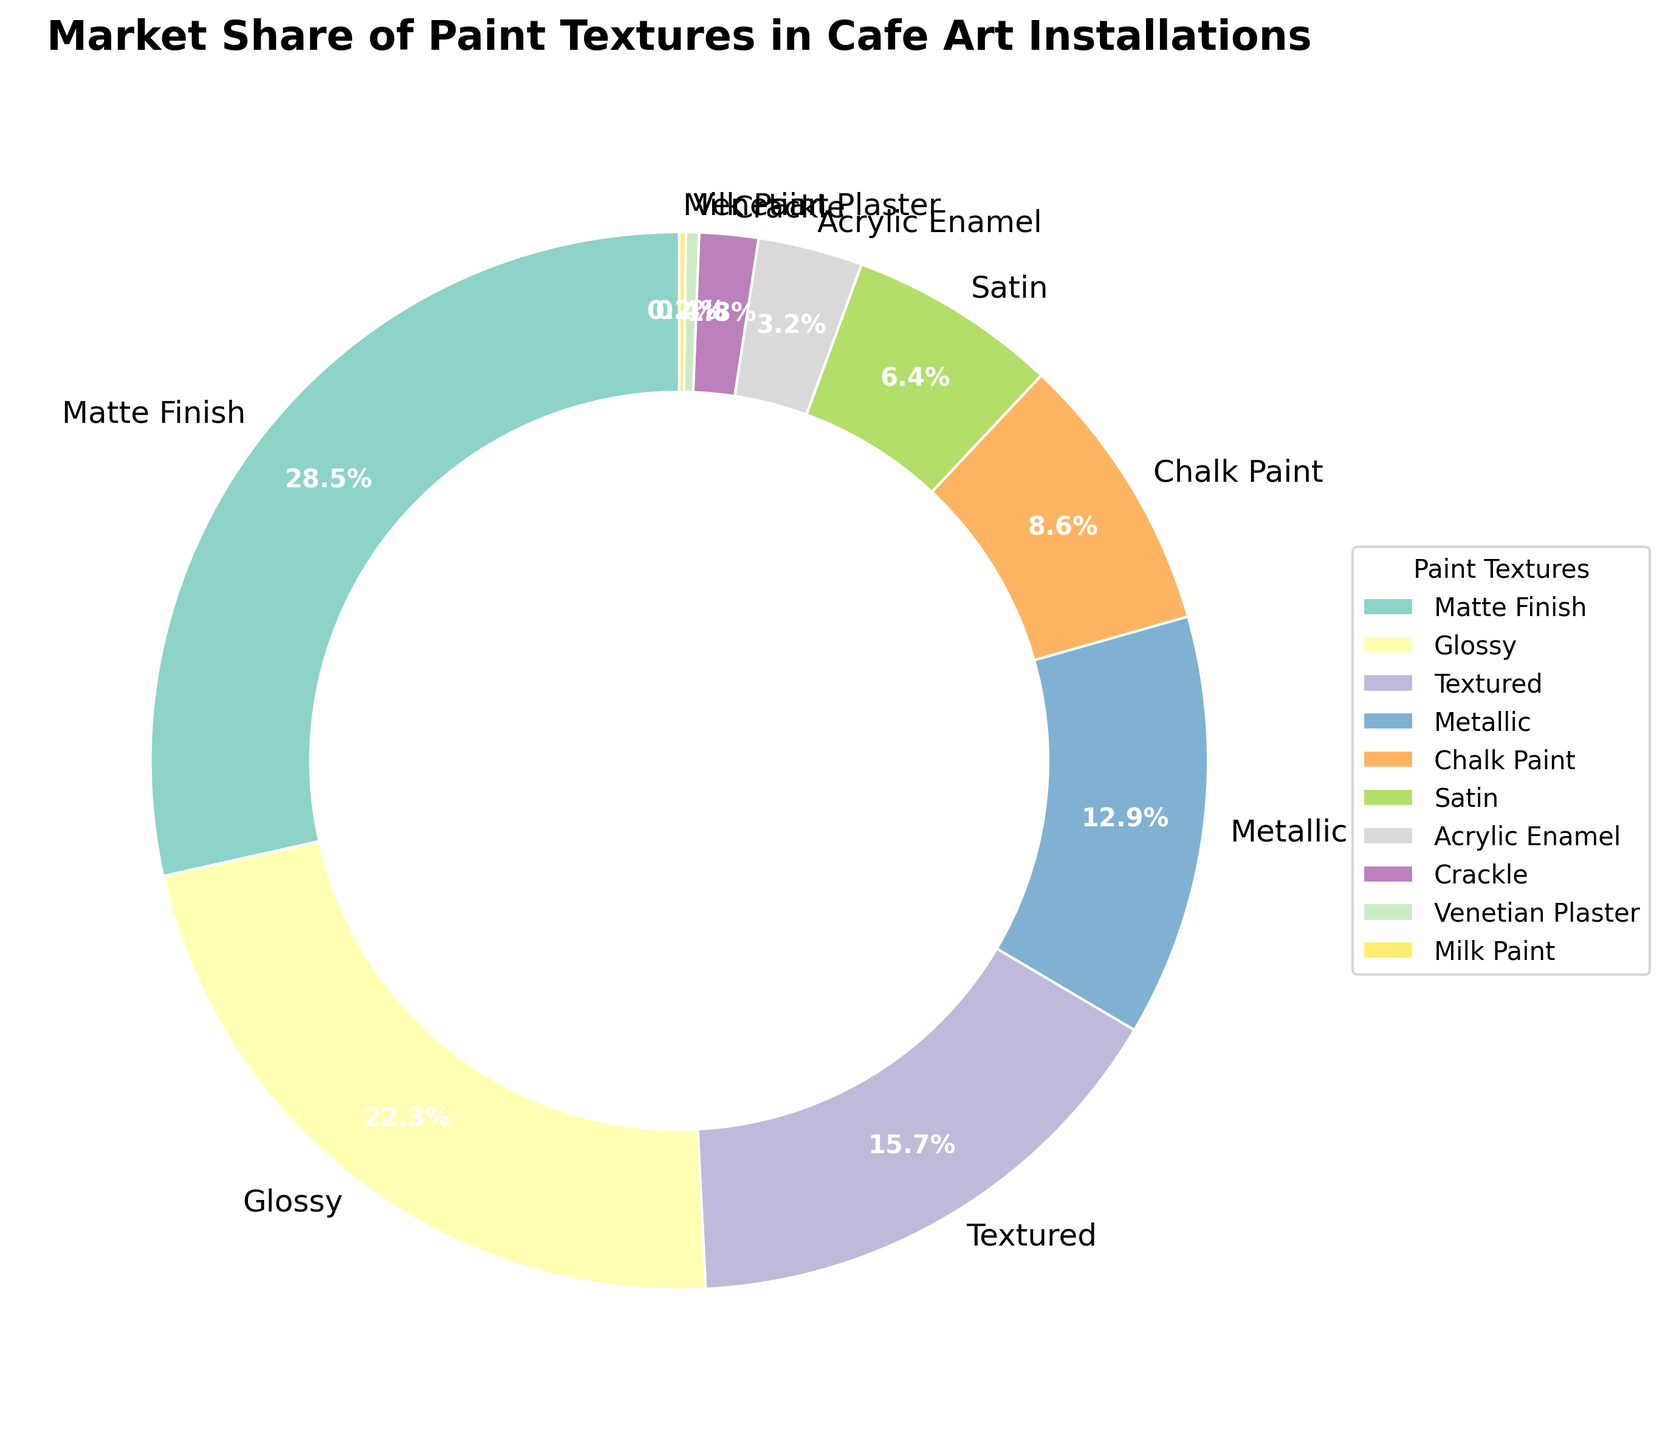Which paint texture has the largest market share? To determine the largest market share, look for the segment with the highest percentage. The "Matte Finish" segment has the largest label showing 28.5%.
Answer: Matte Finish How much more market share does Matte Finish have compared to Glossy? Subtract the market share of Glossy (22.3%) from that of Matte Finish (28.5%): 28.5% - 22.3% = 6.2%.
Answer: 6.2% What is the combined market share of Textured, Metallic, and Chalk Paint? Add the market shares of Textured (15.7%), Metallic (12.9%), and Chalk Paint (8.6%): 15.7% + 12.9% + 8.6% = 37.2%.
Answer: 37.2% Which paint texture has the smallest market share and what is its value? Look for the smallest segment by percentage. The "Milk Paint" segment is the smallest with a label showing 0.2%.
Answer: Milk Paint, 0.2% Are there more paint textures with a market share above or below 10%? Count the textures above 10% (Matte Finish, Glossy, Textured, Metallic – 4 textures) and below 10% (Chalk Paint, Satin, Acrylic Enamel, Crackle, Venetian Plaster, Milk Paint – 6 textures). Since 6 is greater than 4, there are more paint textures below 10%.
Answer: Below Which two paint textures combined contribute more than Glossy but less than Matte Finish? Combine the shares of pairs of textures and compare. For instance, Textured (15.7%) + Metallic (12.9%) = 28.6%, which is more than Glossy (22.3%) and slightly more than Matte Finish (28.5%). Refine until a suitable pair is found, for example: Chalk Paint (8.6%) + Metallic (12.9%) = 21.5% < 22.3% < 28.5%
Answer: Chalk Paint and Metallic If another paint texture with a 5% market share is introduced, where would it rank among the existing textures? Arrange the current shares and see where 5% fits: 28.5%, 22.3%, 15.7%, 12.9%, 8.6%, 6.4%, 5%, 3.2%, 1.8%, 0.4%, 0.2%. This new texture would rank 7th.
Answer: 7th What is the total market share of all the textures that have less than 5% market share? Add the market shares of Acrylic Enamel (3.2%), Crackle (1.8%), Venetian Plaster (0.4%), and Milk Paint (0.2%): 3.2% + 1.8% + 0.4% + 0.2% = 5.6%.
Answer: 5.6% From the given textures, how many different colors are used in the donut chart? Observe the different color wedges in the chart. Since each segment is distinctly colored and there are 10 kinds of textures, 10 different colors are used.
Answer: 10 